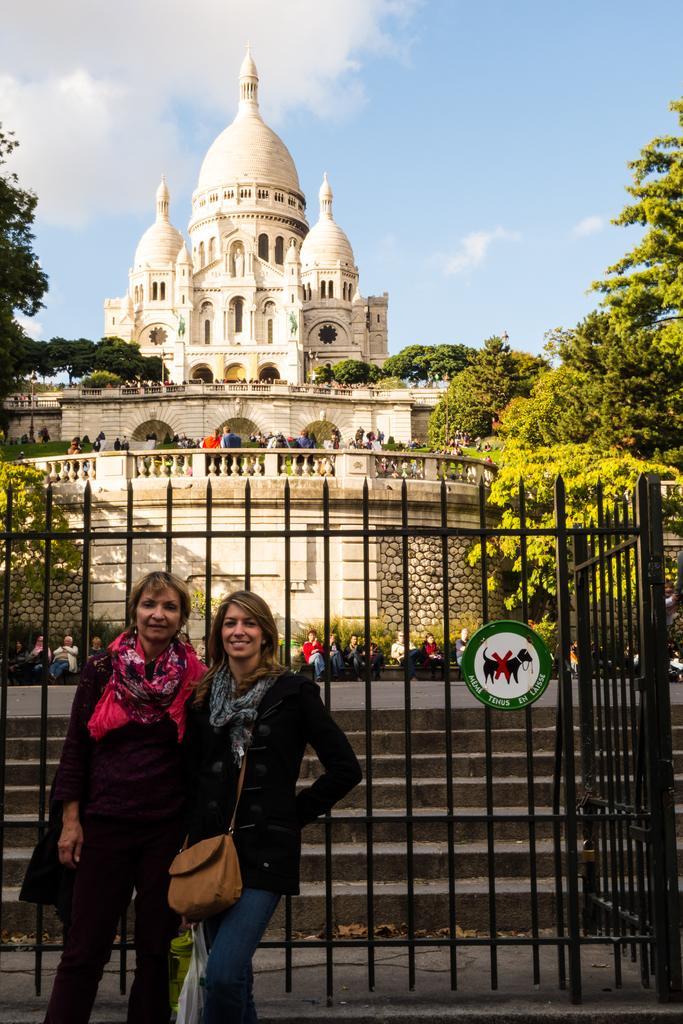How would you summarize this image in a sentence or two? In this picture we can see two women standing here, they are carrying handbags, we can see fencing here, there are stairs here, in the background there are some people sitting here, we can see a building and trees here, there is sky at the top of the picture. 